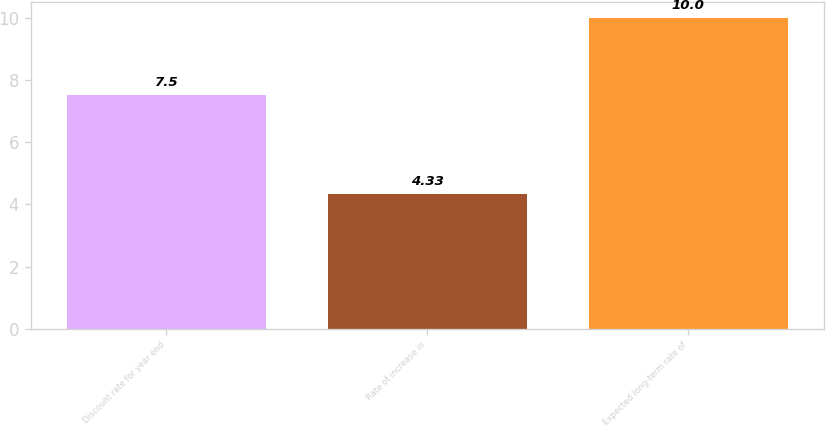Convert chart. <chart><loc_0><loc_0><loc_500><loc_500><bar_chart><fcel>Discount rate for year end<fcel>Rate of increase in<fcel>Expected long-term rate of<nl><fcel>7.5<fcel>4.33<fcel>10<nl></chart> 